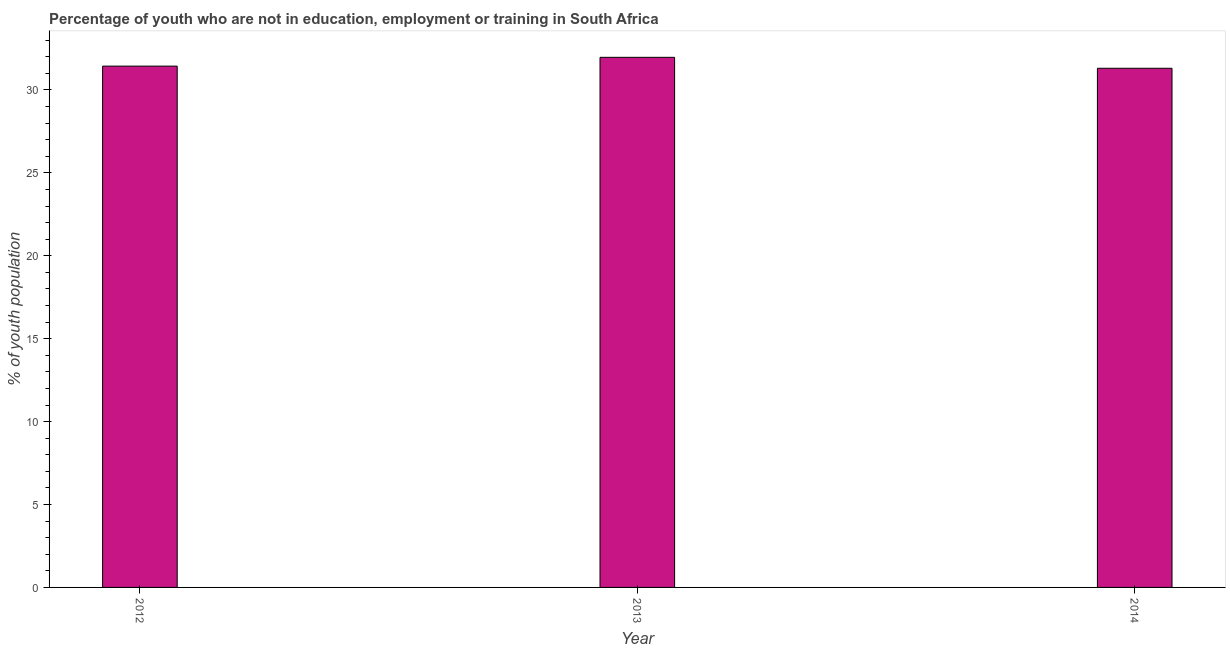Does the graph contain any zero values?
Keep it short and to the point. No. Does the graph contain grids?
Provide a short and direct response. No. What is the title of the graph?
Provide a succinct answer. Percentage of youth who are not in education, employment or training in South Africa. What is the label or title of the X-axis?
Offer a very short reply. Year. What is the label or title of the Y-axis?
Offer a terse response. % of youth population. What is the unemployed youth population in 2012?
Keep it short and to the point. 31.44. Across all years, what is the maximum unemployed youth population?
Offer a very short reply. 31.97. Across all years, what is the minimum unemployed youth population?
Provide a succinct answer. 31.31. In which year was the unemployed youth population maximum?
Make the answer very short. 2013. What is the sum of the unemployed youth population?
Offer a very short reply. 94.72. What is the difference between the unemployed youth population in 2013 and 2014?
Provide a succinct answer. 0.66. What is the average unemployed youth population per year?
Provide a short and direct response. 31.57. What is the median unemployed youth population?
Provide a short and direct response. 31.44. Do a majority of the years between 2013 and 2012 (inclusive) have unemployed youth population greater than 9 %?
Give a very brief answer. No. What is the ratio of the unemployed youth population in 2012 to that in 2014?
Provide a short and direct response. 1. Is the difference between the unemployed youth population in 2012 and 2014 greater than the difference between any two years?
Keep it short and to the point. No. What is the difference between the highest and the second highest unemployed youth population?
Your answer should be very brief. 0.53. Is the sum of the unemployed youth population in 2012 and 2013 greater than the maximum unemployed youth population across all years?
Give a very brief answer. Yes. What is the difference between the highest and the lowest unemployed youth population?
Give a very brief answer. 0.66. In how many years, is the unemployed youth population greater than the average unemployed youth population taken over all years?
Keep it short and to the point. 1. Are all the bars in the graph horizontal?
Provide a short and direct response. No. What is the difference between two consecutive major ticks on the Y-axis?
Your answer should be very brief. 5. Are the values on the major ticks of Y-axis written in scientific E-notation?
Your response must be concise. No. What is the % of youth population in 2012?
Give a very brief answer. 31.44. What is the % of youth population of 2013?
Offer a terse response. 31.97. What is the % of youth population in 2014?
Your answer should be compact. 31.31. What is the difference between the % of youth population in 2012 and 2013?
Your answer should be very brief. -0.53. What is the difference between the % of youth population in 2012 and 2014?
Provide a short and direct response. 0.13. What is the difference between the % of youth population in 2013 and 2014?
Keep it short and to the point. 0.66. What is the ratio of the % of youth population in 2012 to that in 2014?
Provide a short and direct response. 1. 